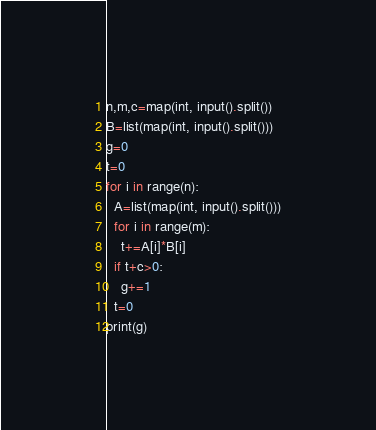<code> <loc_0><loc_0><loc_500><loc_500><_Python_>n,m,c=map(int, input().split())
B=list(map(int, input().split()))
g=0
t=0
for i in range(n):
  A=list(map(int, input().split()))
  for i in range(m):
    t+=A[i]*B[i]
  if t+c>0:
    g+=1
  t=0
print(g)
</code> 